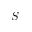Convert formula to latex. <formula><loc_0><loc_0><loc_500><loc_500>S</formula> 